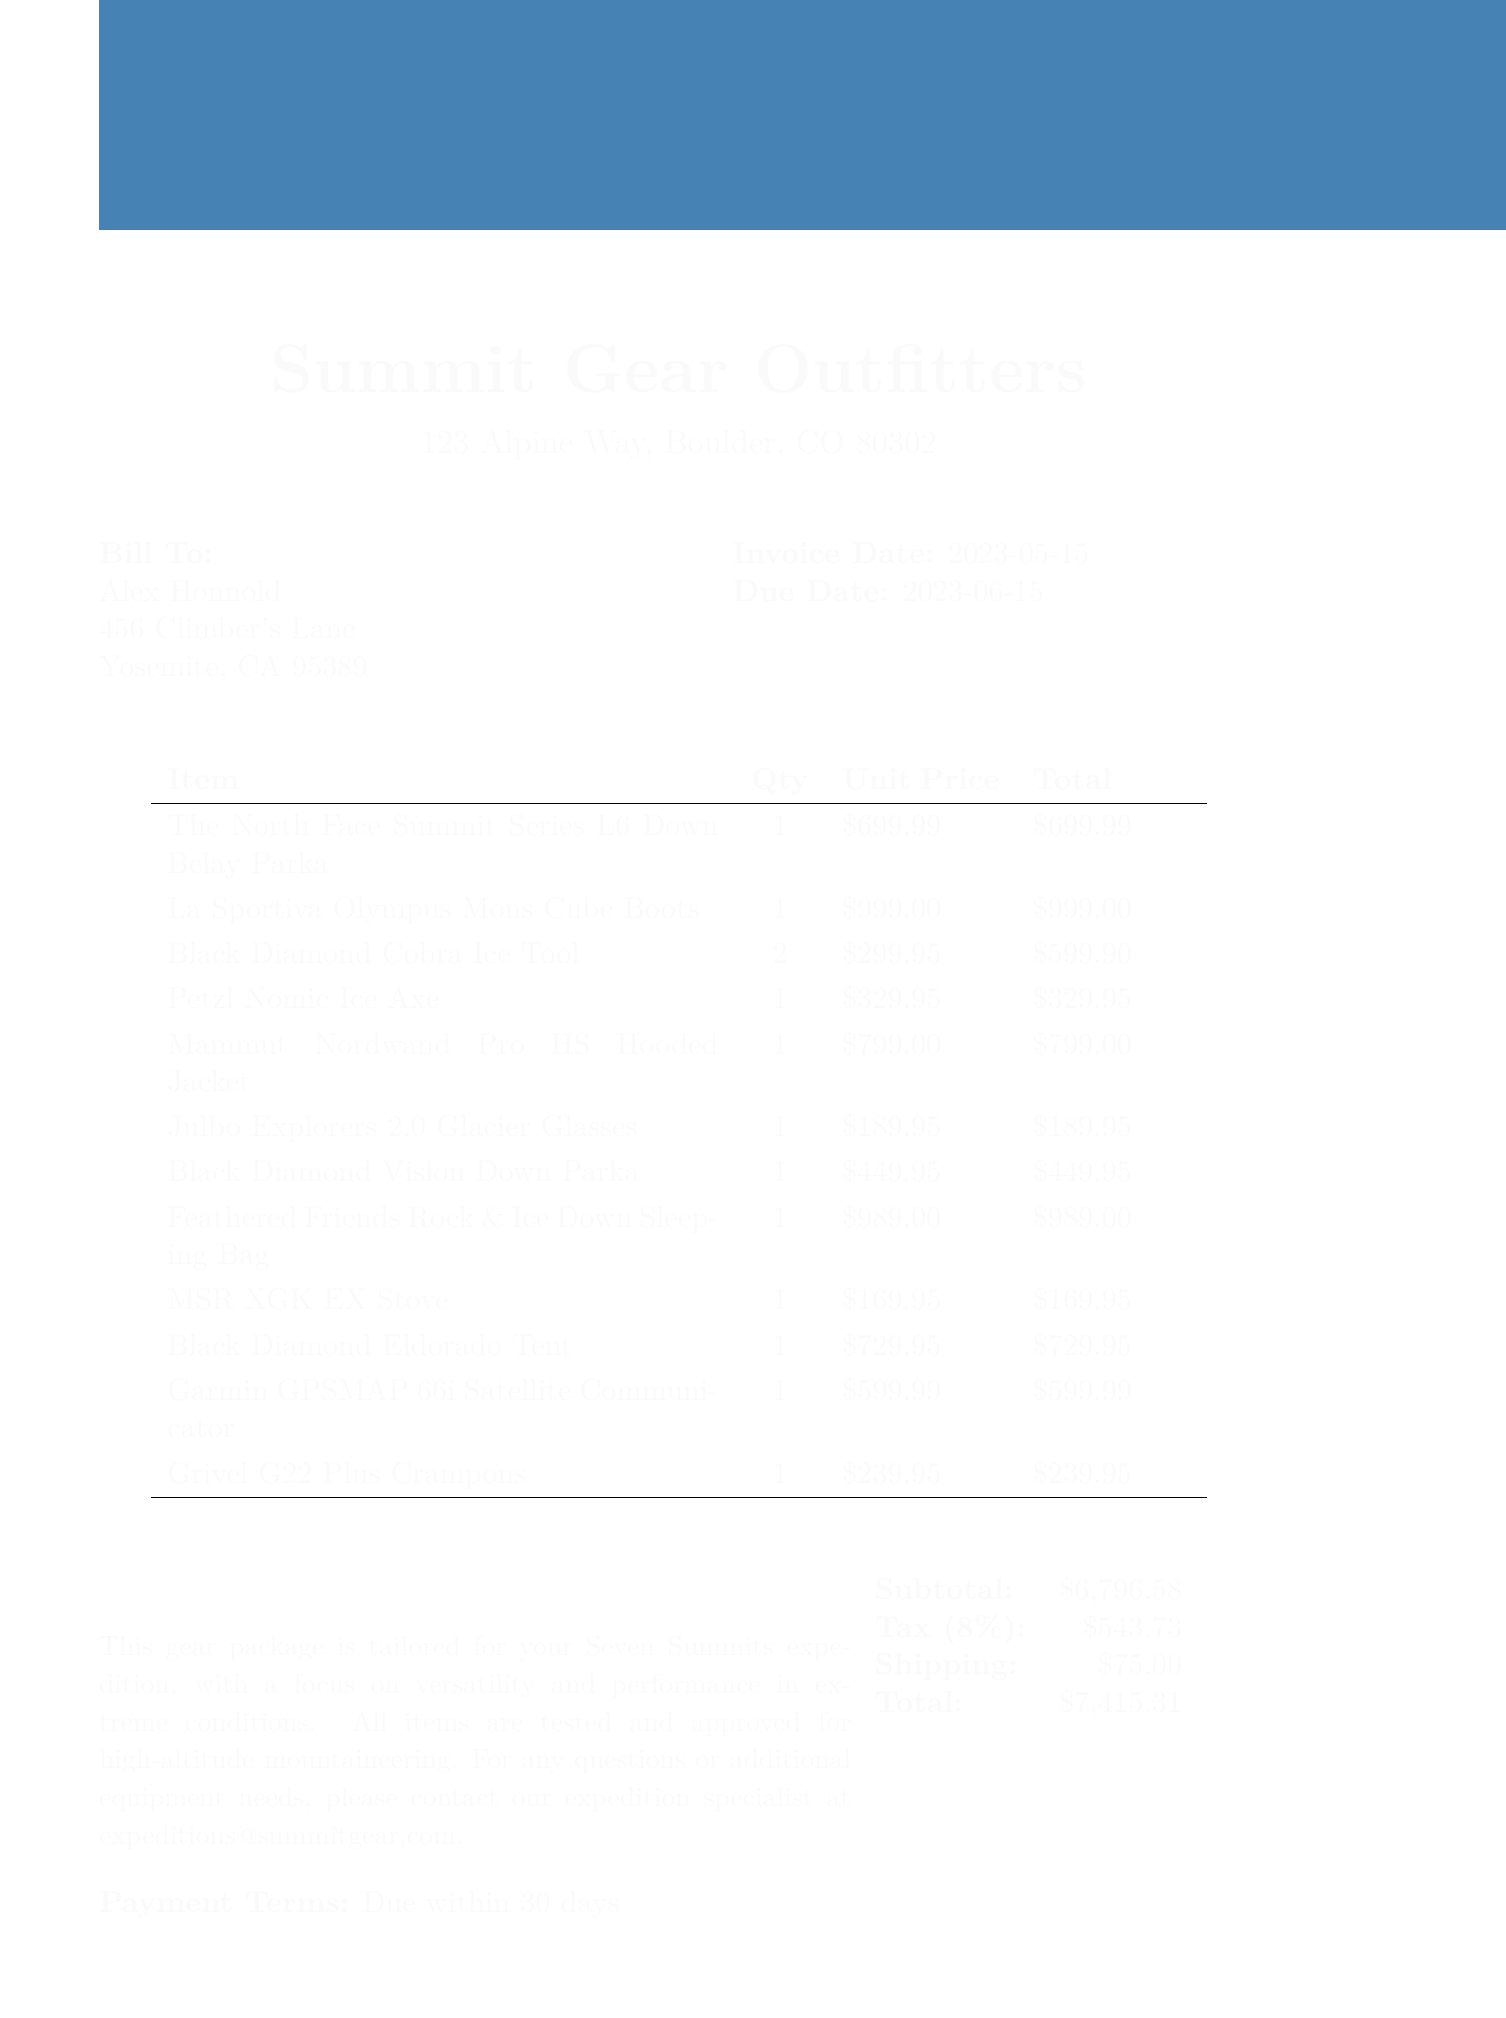What is the invoice number? The invoice number is listed at the top of the document.
Answer: INV-7S2023-001 Who is the customer? The customer's name is indicated near the billing information.
Answer: Alex Honnold What is the total amount due? The total amount is calculated and stated in the financial summary section.
Answer: $7,415.31 How many Black Diamond Cobra Ice Tools were purchased? The quantity of Black Diamond Cobra Ice Tools is specified in the items section.
Answer: 2 What is the payment term? The payment terms are provided in the document as a separate section.
Answer: Due within 30 days What is the tax rate applied? The tax rate is listed in the financial summary section of the document.
Answer: 8% What is the shipping fee? The shipping fee is detailed in the financial summary section.
Answer: $75.00 What type of jacket is included in the gear package? The type of jacket is described in the items section with its name and description.
Answer: Mammut Nordwand Pro HS Hooded Jacket How much does the La Sportiva Olympus Mons Cube Boots cost? The unit price for the La Sportiva Olympus Mons Cube Boots is stated alongside the item.
Answer: $999.00 